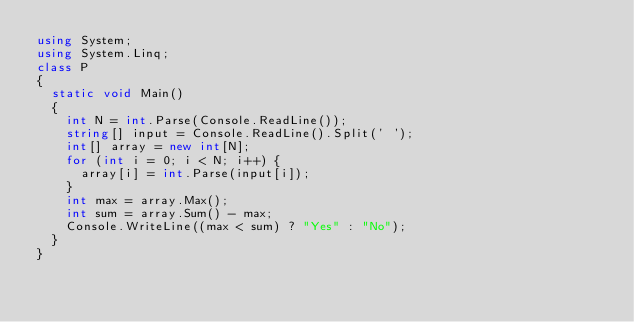<code> <loc_0><loc_0><loc_500><loc_500><_C#_>using System;
using System.Linq;
class P
{
  static void Main()
  {
    int N = int.Parse(Console.ReadLine());
    string[] input = Console.ReadLine().Split(' ');
    int[] array = new int[N];
    for (int i = 0; i < N; i++) {
      array[i] = int.Parse(input[i]);
    }
    int max = array.Max();
    int sum = array.Sum() - max;
    Console.WriteLine((max < sum) ? "Yes" : "No");
  }
}</code> 